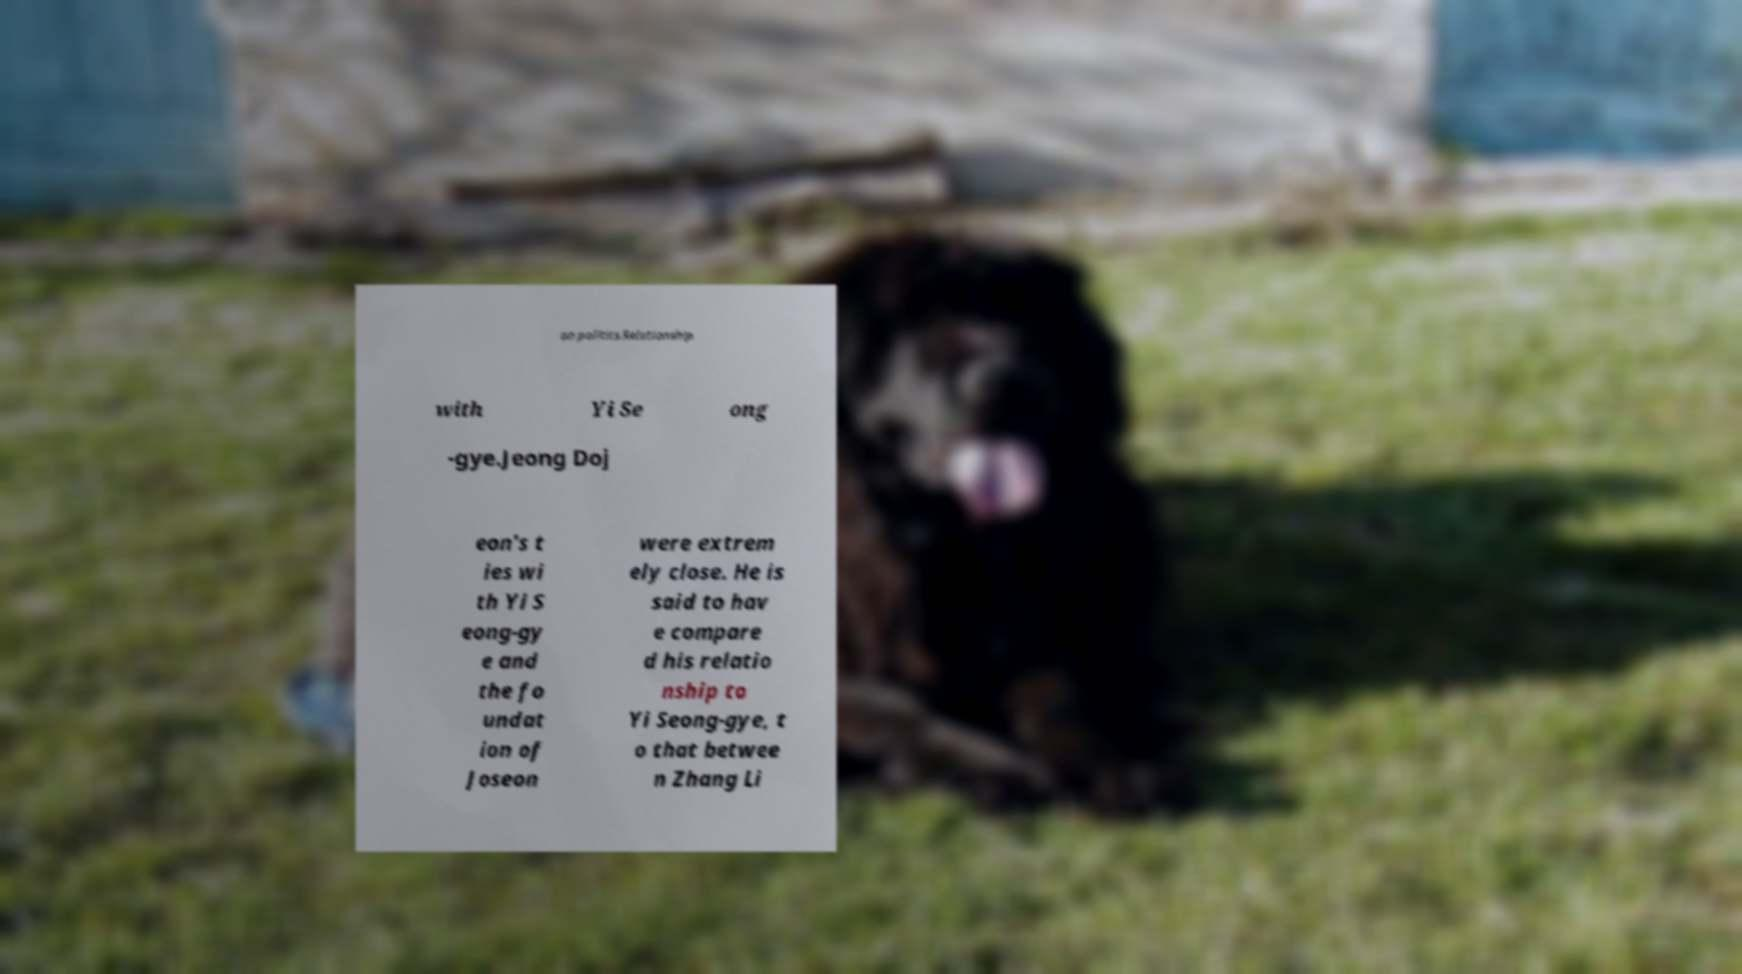Please read and relay the text visible in this image. What does it say? an politics.Relationship with Yi Se ong -gye.Jeong Doj eon's t ies wi th Yi S eong-gy e and the fo undat ion of Joseon were extrem ely close. He is said to hav e compare d his relatio nship to Yi Seong-gye, t o that betwee n Zhang Li 